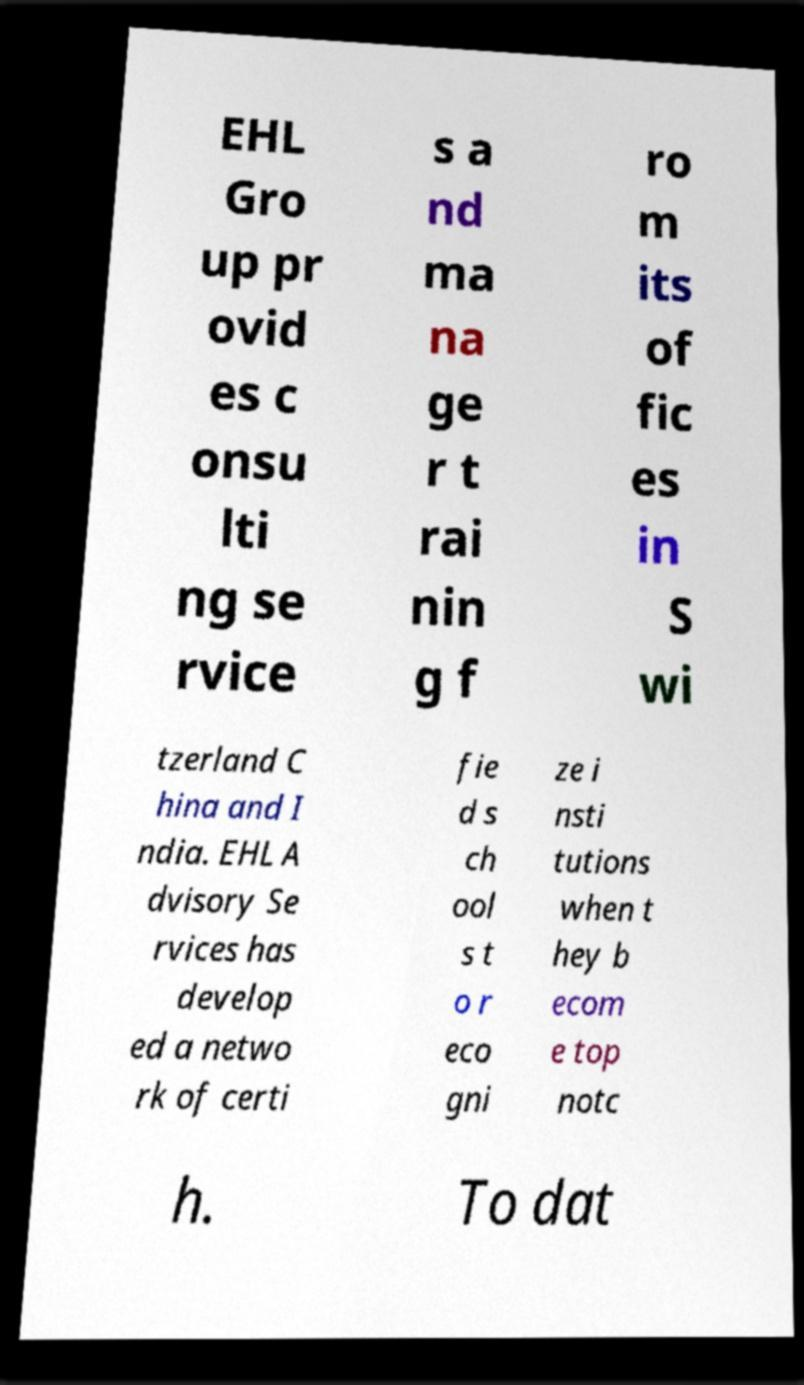I need the written content from this picture converted into text. Can you do that? EHL Gro up pr ovid es c onsu lti ng se rvice s a nd ma na ge r t rai nin g f ro m its of fic es in S wi tzerland C hina and I ndia. EHL A dvisory Se rvices has develop ed a netwo rk of certi fie d s ch ool s t o r eco gni ze i nsti tutions when t hey b ecom e top notc h. To dat 